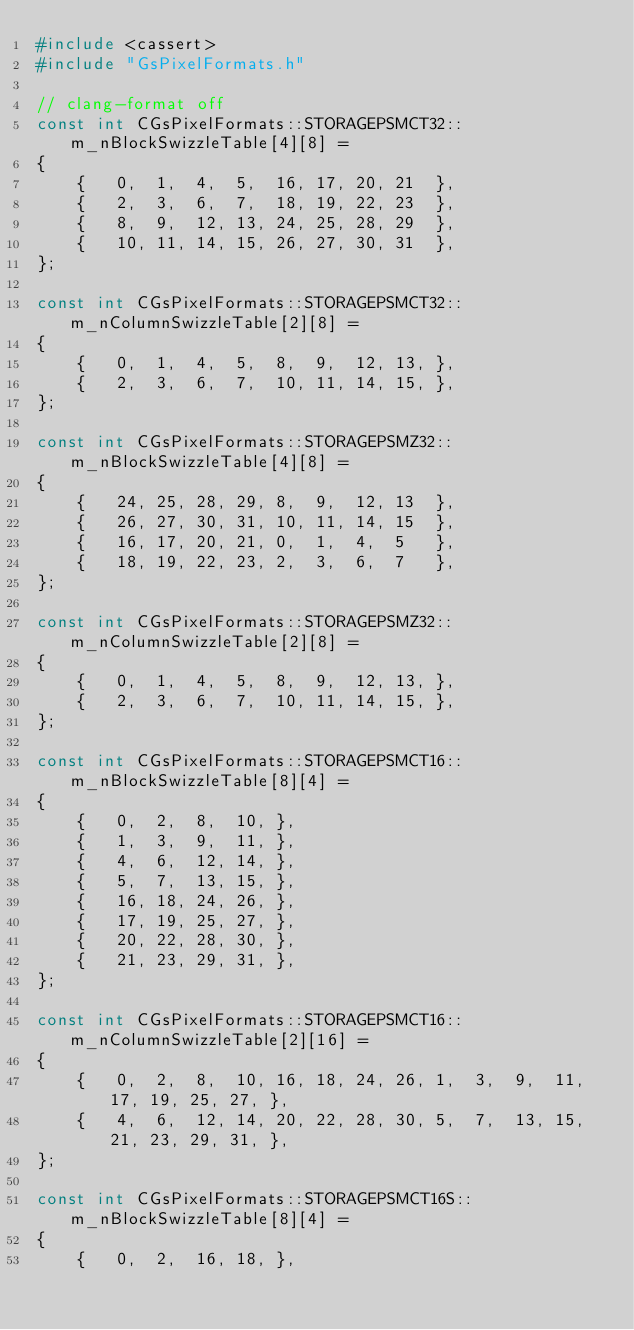<code> <loc_0><loc_0><loc_500><loc_500><_C++_>#include <cassert>
#include "GsPixelFormats.h"

// clang-format off
const int CGsPixelFormats::STORAGEPSMCT32::m_nBlockSwizzleTable[4][8] =
{
	{	0,	1,	4,	5,	16,	17,	20,	21	},
	{	2,	3,	6,	7,	18,	19,	22,	23	},
	{	8,	9,	12,	13,	24,	25,	28,	29	},
	{	10,	11,	14,	15,	26,	27,	30,	31	},
};

const int CGsPixelFormats::STORAGEPSMCT32::m_nColumnSwizzleTable[2][8] =
{
	{	0,	1,	4,	5,	8,	9,	12,	13,	},
	{	2,	3,	6,	7,	10,	11,	14,	15,	},
};

const int CGsPixelFormats::STORAGEPSMZ32::m_nBlockSwizzleTable[4][8] =
{
	{	24,	25,	28,	29,	8,	9,	12,	13	},
	{	26,	27,	30,	31,	10,	11,	14,	15	},
	{	16,	17,	20,	21,	0,	1,	4,	5	},
	{	18,	19,	22,	23,	2,	3,	6,	7	},
};

const int CGsPixelFormats::STORAGEPSMZ32::m_nColumnSwizzleTable[2][8] =
{
	{	0,	1,	4,	5,	8,	9,	12,	13,	},
	{	2,	3,	6,	7,	10,	11,	14,	15,	},
};

const int CGsPixelFormats::STORAGEPSMCT16::m_nBlockSwizzleTable[8][4] =
{
	{	0,	2,	8,	10,	},
	{	1,	3,	9,	11,	},
	{	4,	6,	12,	14,	},
	{	5,	7,	13,	15,	},
	{	16,	18,	24,	26,	},
	{	17,	19,	25,	27,	},
	{	20,	22,	28,	30,	},
	{	21,	23,	29,	31,	},
};

const int CGsPixelFormats::STORAGEPSMCT16::m_nColumnSwizzleTable[2][16] =
{
	{	0,	2,	8,	10,	16,	18,	24,	26,	1,	3,	9,	11,	17,	19,	25,	27,	},
	{	4,	6,	12,	14,	20,	22,	28,	30,	5,	7,	13,	15,	21,	23,	29,	31,	},
};

const int CGsPixelFormats::STORAGEPSMCT16S::m_nBlockSwizzleTable[8][4] =
{
	{	0,	2,	16,	18,	},</code> 